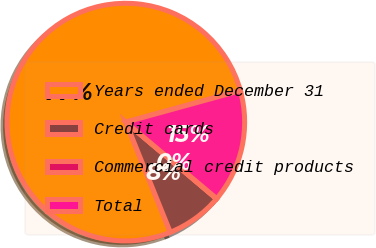<chart> <loc_0><loc_0><loc_500><loc_500><pie_chart><fcel>Years ended December 31<fcel>Credit cards<fcel>Commercial credit products<fcel>Total<nl><fcel>76.84%<fcel>7.72%<fcel>0.04%<fcel>15.4%<nl></chart> 